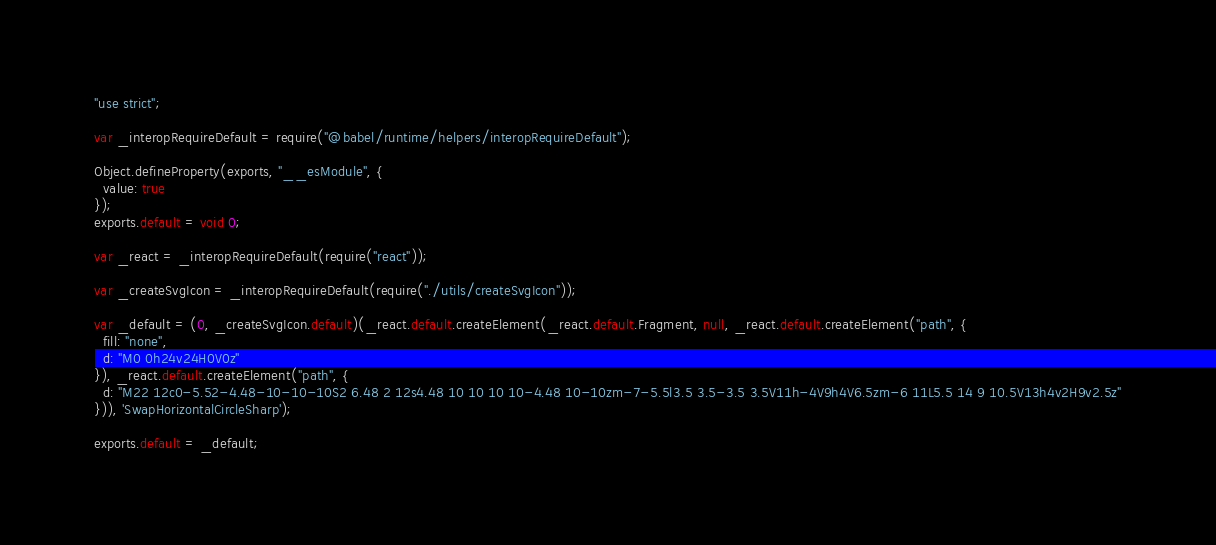<code> <loc_0><loc_0><loc_500><loc_500><_JavaScript_>"use strict";

var _interopRequireDefault = require("@babel/runtime/helpers/interopRequireDefault");

Object.defineProperty(exports, "__esModule", {
  value: true
});
exports.default = void 0;

var _react = _interopRequireDefault(require("react"));

var _createSvgIcon = _interopRequireDefault(require("./utils/createSvgIcon"));

var _default = (0, _createSvgIcon.default)(_react.default.createElement(_react.default.Fragment, null, _react.default.createElement("path", {
  fill: "none",
  d: "M0 0h24v24H0V0z"
}), _react.default.createElement("path", {
  d: "M22 12c0-5.52-4.48-10-10-10S2 6.48 2 12s4.48 10 10 10 10-4.48 10-10zm-7-5.5l3.5 3.5-3.5 3.5V11h-4V9h4V6.5zm-6 11L5.5 14 9 10.5V13h4v2H9v2.5z"
})), 'SwapHorizontalCircleSharp');

exports.default = _default;</code> 